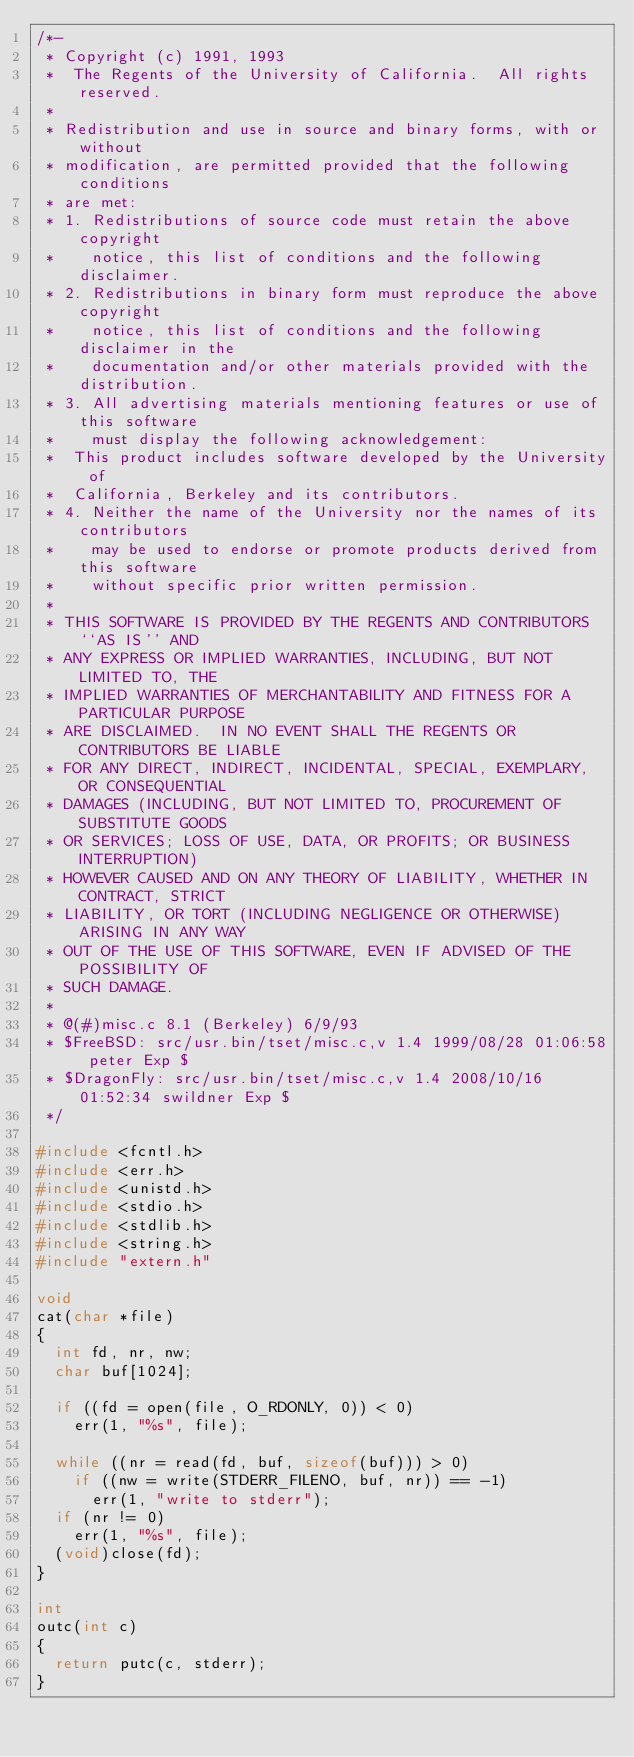<code> <loc_0><loc_0><loc_500><loc_500><_C_>/*-
 * Copyright (c) 1991, 1993
 *	The Regents of the University of California.  All rights reserved.
 *
 * Redistribution and use in source and binary forms, with or without
 * modification, are permitted provided that the following conditions
 * are met:
 * 1. Redistributions of source code must retain the above copyright
 *    notice, this list of conditions and the following disclaimer.
 * 2. Redistributions in binary form must reproduce the above copyright
 *    notice, this list of conditions and the following disclaimer in the
 *    documentation and/or other materials provided with the distribution.
 * 3. All advertising materials mentioning features or use of this software
 *    must display the following acknowledgement:
 *	This product includes software developed by the University of
 *	California, Berkeley and its contributors.
 * 4. Neither the name of the University nor the names of its contributors
 *    may be used to endorse or promote products derived from this software
 *    without specific prior written permission.
 *
 * THIS SOFTWARE IS PROVIDED BY THE REGENTS AND CONTRIBUTORS ``AS IS'' AND
 * ANY EXPRESS OR IMPLIED WARRANTIES, INCLUDING, BUT NOT LIMITED TO, THE
 * IMPLIED WARRANTIES OF MERCHANTABILITY AND FITNESS FOR A PARTICULAR PURPOSE
 * ARE DISCLAIMED.  IN NO EVENT SHALL THE REGENTS OR CONTRIBUTORS BE LIABLE
 * FOR ANY DIRECT, INDIRECT, INCIDENTAL, SPECIAL, EXEMPLARY, OR CONSEQUENTIAL
 * DAMAGES (INCLUDING, BUT NOT LIMITED TO, PROCUREMENT OF SUBSTITUTE GOODS
 * OR SERVICES; LOSS OF USE, DATA, OR PROFITS; OR BUSINESS INTERRUPTION)
 * HOWEVER CAUSED AND ON ANY THEORY OF LIABILITY, WHETHER IN CONTRACT, STRICT
 * LIABILITY, OR TORT (INCLUDING NEGLIGENCE OR OTHERWISE) ARISING IN ANY WAY
 * OUT OF THE USE OF THIS SOFTWARE, EVEN IF ADVISED OF THE POSSIBILITY OF
 * SUCH DAMAGE.
 *
 * @(#)misc.c	8.1 (Berkeley) 6/9/93
 * $FreeBSD: src/usr.bin/tset/misc.c,v 1.4 1999/08/28 01:06:58 peter Exp $
 * $DragonFly: src/usr.bin/tset/misc.c,v 1.4 2008/10/16 01:52:34 swildner Exp $
 */

#include <fcntl.h>
#include <err.h>
#include <unistd.h>
#include <stdio.h>
#include <stdlib.h>
#include <string.h>
#include "extern.h"

void
cat(char *file)
{
	int fd, nr, nw;
	char buf[1024];

	if ((fd = open(file, O_RDONLY, 0)) < 0)
		err(1, "%s", file);

	while ((nr = read(fd, buf, sizeof(buf))) > 0)
		if ((nw = write(STDERR_FILENO, buf, nr)) == -1)
			err(1, "write to stderr");
	if (nr != 0)
		err(1, "%s", file);
	(void)close(fd);
}

int
outc(int c)
{
	return putc(c, stderr);
}
</code> 